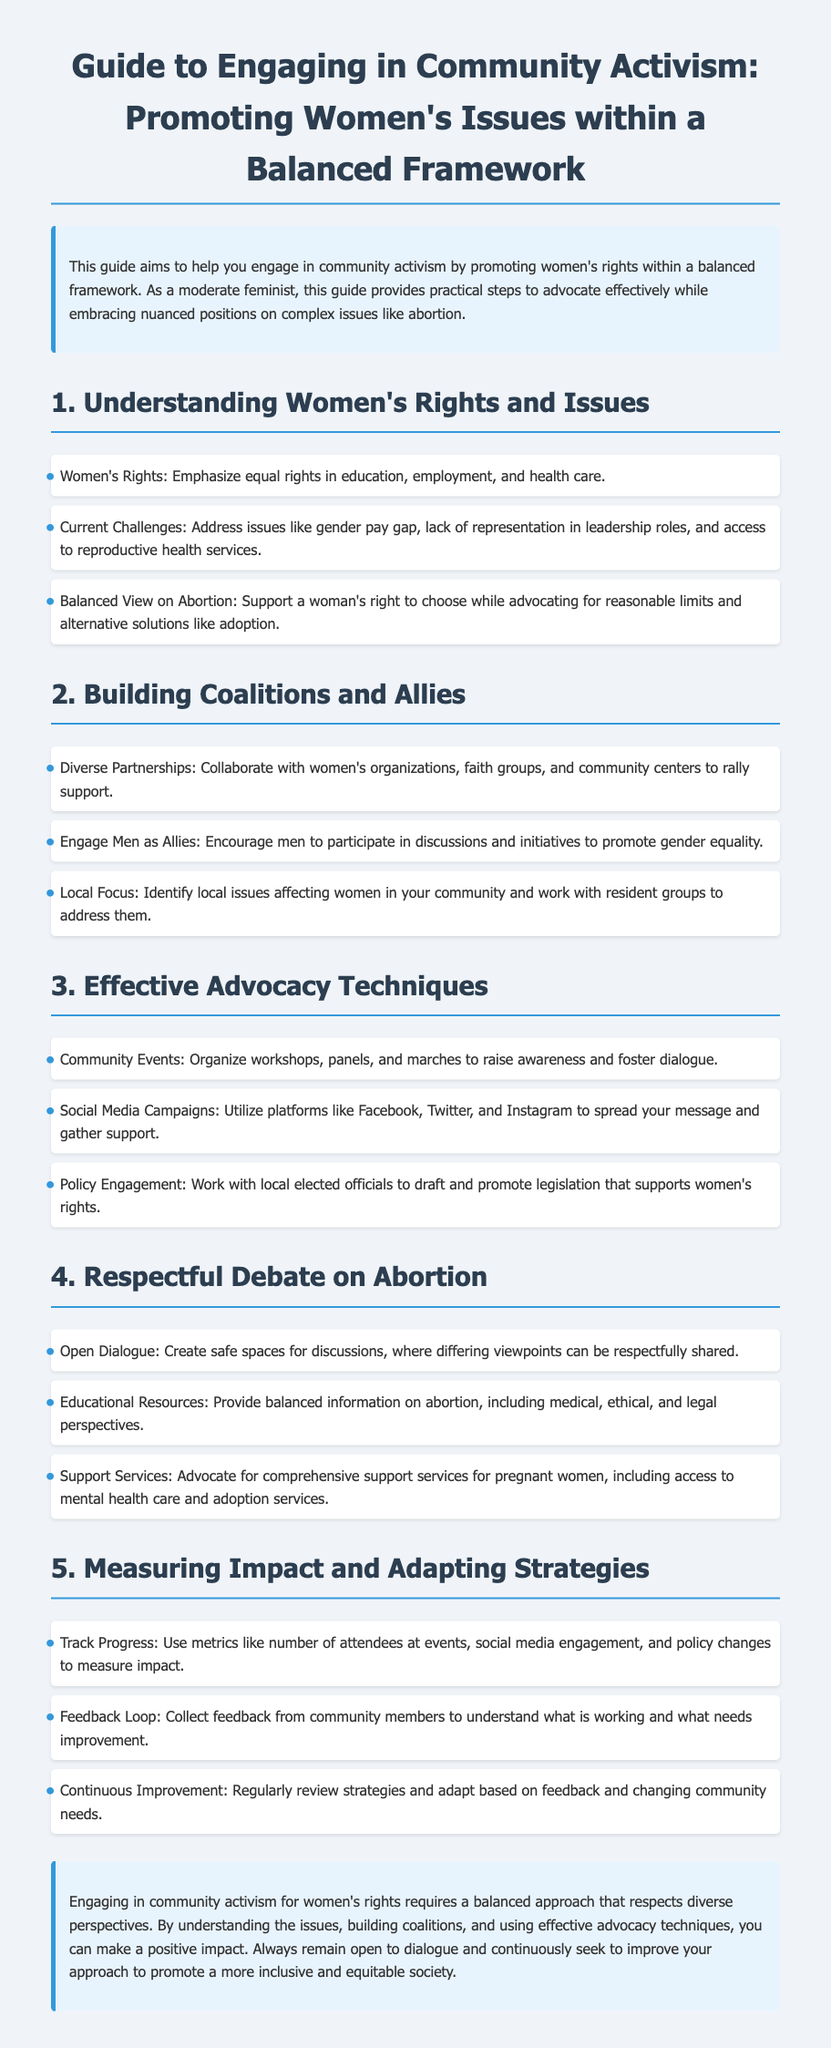What is the title of the document? The title of the document is indicated in the header section, stating its purpose.
Answer: Guide to Engaging in Community Activism: Promoting Women's Issues within a Balanced Framework What is one of the current challenges facing women's rights? The document lists challenges under the section on understanding women's rights and issues, highlighting significant issues.
Answer: Gender pay gap What should you encourage men to do according to the guide? The guide suggests a specific involvement from men in community activism to support gender equality.
Answer: Participate in discussions What is a technique mentioned for effective advocacy? The document provides various techniques for advocacy, showcasing community engagement strategies.
Answer: Organize workshops What does the guide recommend for respectful debate on abortion? The guide emphasizes an important aspect of advocacy related to handling sensitive discussions in a community context.
Answer: Create safe spaces What metric is suggested for measuring impact? The guide encourages tracking certain community activities to evaluate the effectiveness of activism efforts.
Answer: Number of attendees at events What type of resources does the guide suggest providing regarding abortion? The document emphasizes the importance of balanced perspectives in discussions on reproductive rights.
Answer: Educational resources How often should you review strategies according to the guide? The document outlines a specific practice recommended for continual improvement in activism efforts.
Answer: Regularly What is the overall goal of engaging in community activism as stated in the conclusion? The guide concludes with a broad objective related to the impact of community engagement.
Answer: Promote a more inclusive and equitable society 